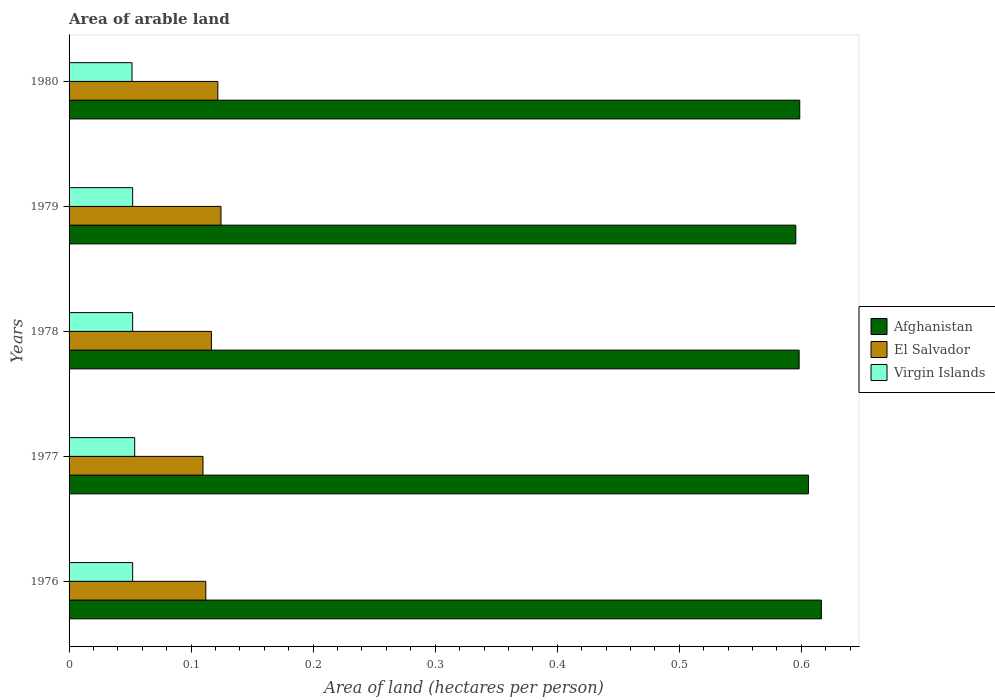Are the number of bars per tick equal to the number of legend labels?
Provide a short and direct response. Yes. Are the number of bars on each tick of the Y-axis equal?
Make the answer very short. Yes. How many bars are there on the 5th tick from the bottom?
Your response must be concise. 3. In how many cases, is the number of bars for a given year not equal to the number of legend labels?
Your response must be concise. 0. What is the total arable land in El Salvador in 1977?
Give a very brief answer. 0.11. Across all years, what is the maximum total arable land in Virgin Islands?
Ensure brevity in your answer.  0.05. Across all years, what is the minimum total arable land in Virgin Islands?
Ensure brevity in your answer.  0.05. In which year was the total arable land in Afghanistan maximum?
Offer a very short reply. 1976. In which year was the total arable land in Afghanistan minimum?
Your answer should be compact. 1979. What is the total total arable land in Afghanistan in the graph?
Your response must be concise. 3.01. What is the difference between the total arable land in Virgin Islands in 1977 and that in 1980?
Ensure brevity in your answer.  0. What is the difference between the total arable land in Afghanistan in 1977 and the total arable land in Virgin Islands in 1976?
Offer a terse response. 0.55. What is the average total arable land in Afghanistan per year?
Keep it short and to the point. 0.6. In the year 1977, what is the difference between the total arable land in Virgin Islands and total arable land in El Salvador?
Keep it short and to the point. -0.06. What is the ratio of the total arable land in Afghanistan in 1976 to that in 1979?
Your response must be concise. 1.04. Is the difference between the total arable land in Virgin Islands in 1979 and 1980 greater than the difference between the total arable land in El Salvador in 1979 and 1980?
Give a very brief answer. No. What is the difference between the highest and the second highest total arable land in El Salvador?
Ensure brevity in your answer.  0. What is the difference between the highest and the lowest total arable land in Virgin Islands?
Offer a terse response. 0. In how many years, is the total arable land in Virgin Islands greater than the average total arable land in Virgin Islands taken over all years?
Provide a succinct answer. 1. What does the 2nd bar from the top in 1978 represents?
Provide a short and direct response. El Salvador. What does the 3rd bar from the bottom in 1980 represents?
Make the answer very short. Virgin Islands. Is it the case that in every year, the sum of the total arable land in Afghanistan and total arable land in Virgin Islands is greater than the total arable land in El Salvador?
Your answer should be compact. Yes. How many bars are there?
Give a very brief answer. 15. Are all the bars in the graph horizontal?
Offer a very short reply. Yes. How many years are there in the graph?
Your response must be concise. 5. What is the difference between two consecutive major ticks on the X-axis?
Your answer should be very brief. 0.1. Are the values on the major ticks of X-axis written in scientific E-notation?
Your answer should be very brief. No. Where does the legend appear in the graph?
Your response must be concise. Center right. How many legend labels are there?
Keep it short and to the point. 3. How are the legend labels stacked?
Offer a very short reply. Vertical. What is the title of the graph?
Offer a very short reply. Area of arable land. What is the label or title of the X-axis?
Your answer should be compact. Area of land (hectares per person). What is the label or title of the Y-axis?
Make the answer very short. Years. What is the Area of land (hectares per person) of Afghanistan in 1976?
Your answer should be compact. 0.62. What is the Area of land (hectares per person) of El Salvador in 1976?
Your answer should be compact. 0.11. What is the Area of land (hectares per person) of Virgin Islands in 1976?
Offer a terse response. 0.05. What is the Area of land (hectares per person) of Afghanistan in 1977?
Your response must be concise. 0.61. What is the Area of land (hectares per person) of El Salvador in 1977?
Give a very brief answer. 0.11. What is the Area of land (hectares per person) in Virgin Islands in 1977?
Your answer should be compact. 0.05. What is the Area of land (hectares per person) in Afghanistan in 1978?
Your answer should be compact. 0.6. What is the Area of land (hectares per person) of El Salvador in 1978?
Your answer should be very brief. 0.12. What is the Area of land (hectares per person) in Virgin Islands in 1978?
Make the answer very short. 0.05. What is the Area of land (hectares per person) in Afghanistan in 1979?
Keep it short and to the point. 0.6. What is the Area of land (hectares per person) in El Salvador in 1979?
Offer a very short reply. 0.12. What is the Area of land (hectares per person) in Virgin Islands in 1979?
Offer a very short reply. 0.05. What is the Area of land (hectares per person) of Afghanistan in 1980?
Offer a very short reply. 0.6. What is the Area of land (hectares per person) of El Salvador in 1980?
Your answer should be very brief. 0.12. What is the Area of land (hectares per person) of Virgin Islands in 1980?
Give a very brief answer. 0.05. Across all years, what is the maximum Area of land (hectares per person) of Afghanistan?
Offer a very short reply. 0.62. Across all years, what is the maximum Area of land (hectares per person) of El Salvador?
Ensure brevity in your answer.  0.12. Across all years, what is the maximum Area of land (hectares per person) in Virgin Islands?
Your response must be concise. 0.05. Across all years, what is the minimum Area of land (hectares per person) in Afghanistan?
Give a very brief answer. 0.6. Across all years, what is the minimum Area of land (hectares per person) of El Salvador?
Offer a very short reply. 0.11. Across all years, what is the minimum Area of land (hectares per person) in Virgin Islands?
Offer a very short reply. 0.05. What is the total Area of land (hectares per person) in Afghanistan in the graph?
Your response must be concise. 3.01. What is the total Area of land (hectares per person) in El Salvador in the graph?
Ensure brevity in your answer.  0.58. What is the total Area of land (hectares per person) in Virgin Islands in the graph?
Give a very brief answer. 0.26. What is the difference between the Area of land (hectares per person) of Afghanistan in 1976 and that in 1977?
Offer a terse response. 0.01. What is the difference between the Area of land (hectares per person) in El Salvador in 1976 and that in 1977?
Offer a very short reply. 0. What is the difference between the Area of land (hectares per person) in Virgin Islands in 1976 and that in 1977?
Keep it short and to the point. -0. What is the difference between the Area of land (hectares per person) of Afghanistan in 1976 and that in 1978?
Your answer should be compact. 0.02. What is the difference between the Area of land (hectares per person) of El Salvador in 1976 and that in 1978?
Ensure brevity in your answer.  -0. What is the difference between the Area of land (hectares per person) of Virgin Islands in 1976 and that in 1978?
Provide a succinct answer. 0. What is the difference between the Area of land (hectares per person) of Afghanistan in 1976 and that in 1979?
Make the answer very short. 0.02. What is the difference between the Area of land (hectares per person) in El Salvador in 1976 and that in 1979?
Make the answer very short. -0.01. What is the difference between the Area of land (hectares per person) of Virgin Islands in 1976 and that in 1979?
Give a very brief answer. 0. What is the difference between the Area of land (hectares per person) of Afghanistan in 1976 and that in 1980?
Make the answer very short. 0.02. What is the difference between the Area of land (hectares per person) in El Salvador in 1976 and that in 1980?
Your answer should be very brief. -0.01. What is the difference between the Area of land (hectares per person) in Virgin Islands in 1976 and that in 1980?
Make the answer very short. 0. What is the difference between the Area of land (hectares per person) in Afghanistan in 1977 and that in 1978?
Ensure brevity in your answer.  0.01. What is the difference between the Area of land (hectares per person) in El Salvador in 1977 and that in 1978?
Your response must be concise. -0.01. What is the difference between the Area of land (hectares per person) of Virgin Islands in 1977 and that in 1978?
Keep it short and to the point. 0. What is the difference between the Area of land (hectares per person) in Afghanistan in 1977 and that in 1979?
Your answer should be compact. 0.01. What is the difference between the Area of land (hectares per person) in El Salvador in 1977 and that in 1979?
Your answer should be very brief. -0.01. What is the difference between the Area of land (hectares per person) in Virgin Islands in 1977 and that in 1979?
Provide a short and direct response. 0. What is the difference between the Area of land (hectares per person) in Afghanistan in 1977 and that in 1980?
Keep it short and to the point. 0.01. What is the difference between the Area of land (hectares per person) of El Salvador in 1977 and that in 1980?
Offer a very short reply. -0.01. What is the difference between the Area of land (hectares per person) of Virgin Islands in 1977 and that in 1980?
Your response must be concise. 0. What is the difference between the Area of land (hectares per person) of Afghanistan in 1978 and that in 1979?
Provide a succinct answer. 0. What is the difference between the Area of land (hectares per person) in El Salvador in 1978 and that in 1979?
Your response must be concise. -0.01. What is the difference between the Area of land (hectares per person) of Afghanistan in 1978 and that in 1980?
Give a very brief answer. -0. What is the difference between the Area of land (hectares per person) of El Salvador in 1978 and that in 1980?
Make the answer very short. -0.01. What is the difference between the Area of land (hectares per person) of Afghanistan in 1979 and that in 1980?
Give a very brief answer. -0. What is the difference between the Area of land (hectares per person) in El Salvador in 1979 and that in 1980?
Provide a succinct answer. 0. What is the difference between the Area of land (hectares per person) of Afghanistan in 1976 and the Area of land (hectares per person) of El Salvador in 1977?
Your answer should be compact. 0.51. What is the difference between the Area of land (hectares per person) of Afghanistan in 1976 and the Area of land (hectares per person) of Virgin Islands in 1977?
Your answer should be compact. 0.56. What is the difference between the Area of land (hectares per person) of El Salvador in 1976 and the Area of land (hectares per person) of Virgin Islands in 1977?
Your answer should be compact. 0.06. What is the difference between the Area of land (hectares per person) of Afghanistan in 1976 and the Area of land (hectares per person) of El Salvador in 1978?
Offer a terse response. 0.5. What is the difference between the Area of land (hectares per person) of Afghanistan in 1976 and the Area of land (hectares per person) of Virgin Islands in 1978?
Make the answer very short. 0.56. What is the difference between the Area of land (hectares per person) in El Salvador in 1976 and the Area of land (hectares per person) in Virgin Islands in 1978?
Give a very brief answer. 0.06. What is the difference between the Area of land (hectares per person) in Afghanistan in 1976 and the Area of land (hectares per person) in El Salvador in 1979?
Provide a short and direct response. 0.49. What is the difference between the Area of land (hectares per person) of Afghanistan in 1976 and the Area of land (hectares per person) of Virgin Islands in 1979?
Give a very brief answer. 0.56. What is the difference between the Area of land (hectares per person) in El Salvador in 1976 and the Area of land (hectares per person) in Virgin Islands in 1979?
Offer a terse response. 0.06. What is the difference between the Area of land (hectares per person) in Afghanistan in 1976 and the Area of land (hectares per person) in El Salvador in 1980?
Give a very brief answer. 0.49. What is the difference between the Area of land (hectares per person) in Afghanistan in 1976 and the Area of land (hectares per person) in Virgin Islands in 1980?
Offer a terse response. 0.56. What is the difference between the Area of land (hectares per person) in El Salvador in 1976 and the Area of land (hectares per person) in Virgin Islands in 1980?
Offer a very short reply. 0.06. What is the difference between the Area of land (hectares per person) of Afghanistan in 1977 and the Area of land (hectares per person) of El Salvador in 1978?
Offer a very short reply. 0.49. What is the difference between the Area of land (hectares per person) of Afghanistan in 1977 and the Area of land (hectares per person) of Virgin Islands in 1978?
Make the answer very short. 0.55. What is the difference between the Area of land (hectares per person) of El Salvador in 1977 and the Area of land (hectares per person) of Virgin Islands in 1978?
Keep it short and to the point. 0.06. What is the difference between the Area of land (hectares per person) of Afghanistan in 1977 and the Area of land (hectares per person) of El Salvador in 1979?
Make the answer very short. 0.48. What is the difference between the Area of land (hectares per person) in Afghanistan in 1977 and the Area of land (hectares per person) in Virgin Islands in 1979?
Provide a short and direct response. 0.55. What is the difference between the Area of land (hectares per person) of El Salvador in 1977 and the Area of land (hectares per person) of Virgin Islands in 1979?
Your response must be concise. 0.06. What is the difference between the Area of land (hectares per person) in Afghanistan in 1977 and the Area of land (hectares per person) in El Salvador in 1980?
Your response must be concise. 0.48. What is the difference between the Area of land (hectares per person) of Afghanistan in 1977 and the Area of land (hectares per person) of Virgin Islands in 1980?
Your answer should be very brief. 0.55. What is the difference between the Area of land (hectares per person) of El Salvador in 1977 and the Area of land (hectares per person) of Virgin Islands in 1980?
Provide a succinct answer. 0.06. What is the difference between the Area of land (hectares per person) in Afghanistan in 1978 and the Area of land (hectares per person) in El Salvador in 1979?
Your answer should be very brief. 0.47. What is the difference between the Area of land (hectares per person) of Afghanistan in 1978 and the Area of land (hectares per person) of Virgin Islands in 1979?
Your answer should be compact. 0.55. What is the difference between the Area of land (hectares per person) of El Salvador in 1978 and the Area of land (hectares per person) of Virgin Islands in 1979?
Make the answer very short. 0.06. What is the difference between the Area of land (hectares per person) of Afghanistan in 1978 and the Area of land (hectares per person) of El Salvador in 1980?
Give a very brief answer. 0.48. What is the difference between the Area of land (hectares per person) of Afghanistan in 1978 and the Area of land (hectares per person) of Virgin Islands in 1980?
Offer a very short reply. 0.55. What is the difference between the Area of land (hectares per person) of El Salvador in 1978 and the Area of land (hectares per person) of Virgin Islands in 1980?
Ensure brevity in your answer.  0.07. What is the difference between the Area of land (hectares per person) of Afghanistan in 1979 and the Area of land (hectares per person) of El Salvador in 1980?
Your answer should be compact. 0.47. What is the difference between the Area of land (hectares per person) in Afghanistan in 1979 and the Area of land (hectares per person) in Virgin Islands in 1980?
Offer a very short reply. 0.54. What is the difference between the Area of land (hectares per person) of El Salvador in 1979 and the Area of land (hectares per person) of Virgin Islands in 1980?
Provide a short and direct response. 0.07. What is the average Area of land (hectares per person) of Afghanistan per year?
Your response must be concise. 0.6. What is the average Area of land (hectares per person) in El Salvador per year?
Your answer should be compact. 0.12. What is the average Area of land (hectares per person) of Virgin Islands per year?
Your answer should be very brief. 0.05. In the year 1976, what is the difference between the Area of land (hectares per person) of Afghanistan and Area of land (hectares per person) of El Salvador?
Provide a short and direct response. 0.5. In the year 1976, what is the difference between the Area of land (hectares per person) in Afghanistan and Area of land (hectares per person) in Virgin Islands?
Make the answer very short. 0.56. In the year 1977, what is the difference between the Area of land (hectares per person) of Afghanistan and Area of land (hectares per person) of El Salvador?
Offer a terse response. 0.5. In the year 1977, what is the difference between the Area of land (hectares per person) in Afghanistan and Area of land (hectares per person) in Virgin Islands?
Provide a short and direct response. 0.55. In the year 1977, what is the difference between the Area of land (hectares per person) of El Salvador and Area of land (hectares per person) of Virgin Islands?
Offer a very short reply. 0.06. In the year 1978, what is the difference between the Area of land (hectares per person) in Afghanistan and Area of land (hectares per person) in El Salvador?
Offer a terse response. 0.48. In the year 1978, what is the difference between the Area of land (hectares per person) in Afghanistan and Area of land (hectares per person) in Virgin Islands?
Ensure brevity in your answer.  0.55. In the year 1978, what is the difference between the Area of land (hectares per person) in El Salvador and Area of land (hectares per person) in Virgin Islands?
Your answer should be compact. 0.06. In the year 1979, what is the difference between the Area of land (hectares per person) in Afghanistan and Area of land (hectares per person) in El Salvador?
Offer a very short reply. 0.47. In the year 1979, what is the difference between the Area of land (hectares per person) in Afghanistan and Area of land (hectares per person) in Virgin Islands?
Keep it short and to the point. 0.54. In the year 1979, what is the difference between the Area of land (hectares per person) in El Salvador and Area of land (hectares per person) in Virgin Islands?
Give a very brief answer. 0.07. In the year 1980, what is the difference between the Area of land (hectares per person) of Afghanistan and Area of land (hectares per person) of El Salvador?
Offer a terse response. 0.48. In the year 1980, what is the difference between the Area of land (hectares per person) of Afghanistan and Area of land (hectares per person) of Virgin Islands?
Offer a very short reply. 0.55. In the year 1980, what is the difference between the Area of land (hectares per person) in El Salvador and Area of land (hectares per person) in Virgin Islands?
Give a very brief answer. 0.07. What is the ratio of the Area of land (hectares per person) in Afghanistan in 1976 to that in 1977?
Ensure brevity in your answer.  1.02. What is the ratio of the Area of land (hectares per person) in El Salvador in 1976 to that in 1977?
Provide a succinct answer. 1.02. What is the ratio of the Area of land (hectares per person) of Virgin Islands in 1976 to that in 1977?
Keep it short and to the point. 0.97. What is the ratio of the Area of land (hectares per person) of Afghanistan in 1976 to that in 1978?
Your response must be concise. 1.03. What is the ratio of the Area of land (hectares per person) in El Salvador in 1976 to that in 1978?
Provide a short and direct response. 0.96. What is the ratio of the Area of land (hectares per person) in Afghanistan in 1976 to that in 1979?
Offer a terse response. 1.04. What is the ratio of the Area of land (hectares per person) of El Salvador in 1976 to that in 1979?
Make the answer very short. 0.9. What is the ratio of the Area of land (hectares per person) in Virgin Islands in 1976 to that in 1979?
Ensure brevity in your answer.  1. What is the ratio of the Area of land (hectares per person) in Afghanistan in 1976 to that in 1980?
Provide a short and direct response. 1.03. What is the ratio of the Area of land (hectares per person) in El Salvador in 1976 to that in 1980?
Offer a terse response. 0.92. What is the ratio of the Area of land (hectares per person) in Virgin Islands in 1976 to that in 1980?
Your response must be concise. 1.01. What is the ratio of the Area of land (hectares per person) in Afghanistan in 1977 to that in 1978?
Ensure brevity in your answer.  1.01. What is the ratio of the Area of land (hectares per person) in El Salvador in 1977 to that in 1978?
Provide a short and direct response. 0.94. What is the ratio of the Area of land (hectares per person) of Virgin Islands in 1977 to that in 1978?
Give a very brief answer. 1.03. What is the ratio of the Area of land (hectares per person) in Afghanistan in 1977 to that in 1979?
Offer a terse response. 1.02. What is the ratio of the Area of land (hectares per person) in El Salvador in 1977 to that in 1979?
Give a very brief answer. 0.88. What is the ratio of the Area of land (hectares per person) in Virgin Islands in 1977 to that in 1979?
Give a very brief answer. 1.03. What is the ratio of the Area of land (hectares per person) in Afghanistan in 1977 to that in 1980?
Offer a very short reply. 1.01. What is the ratio of the Area of land (hectares per person) in El Salvador in 1977 to that in 1980?
Offer a very short reply. 0.9. What is the ratio of the Area of land (hectares per person) of Virgin Islands in 1977 to that in 1980?
Make the answer very short. 1.04. What is the ratio of the Area of land (hectares per person) in Afghanistan in 1978 to that in 1979?
Your response must be concise. 1. What is the ratio of the Area of land (hectares per person) in El Salvador in 1978 to that in 1979?
Offer a terse response. 0.94. What is the ratio of the Area of land (hectares per person) in Virgin Islands in 1978 to that in 1979?
Your answer should be compact. 1. What is the ratio of the Area of land (hectares per person) in El Salvador in 1978 to that in 1980?
Offer a very short reply. 0.96. What is the ratio of the Area of land (hectares per person) in Virgin Islands in 1978 to that in 1980?
Keep it short and to the point. 1.01. What is the ratio of the Area of land (hectares per person) of El Salvador in 1979 to that in 1980?
Your answer should be compact. 1.02. What is the ratio of the Area of land (hectares per person) in Virgin Islands in 1979 to that in 1980?
Offer a terse response. 1.01. What is the difference between the highest and the second highest Area of land (hectares per person) of Afghanistan?
Your answer should be very brief. 0.01. What is the difference between the highest and the second highest Area of land (hectares per person) in El Salvador?
Your answer should be very brief. 0. What is the difference between the highest and the second highest Area of land (hectares per person) of Virgin Islands?
Offer a terse response. 0. What is the difference between the highest and the lowest Area of land (hectares per person) of Afghanistan?
Ensure brevity in your answer.  0.02. What is the difference between the highest and the lowest Area of land (hectares per person) of El Salvador?
Ensure brevity in your answer.  0.01. What is the difference between the highest and the lowest Area of land (hectares per person) in Virgin Islands?
Provide a short and direct response. 0. 